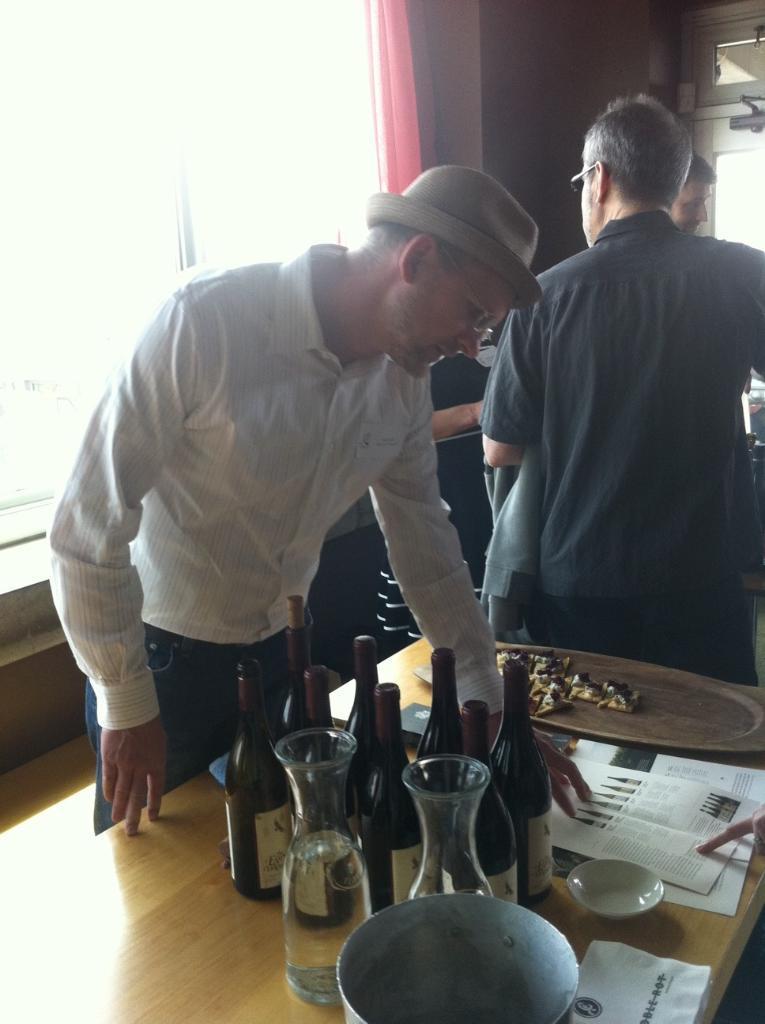Could you give a brief overview of what you see in this image? In this image, I can see few people standing. At the bottom of the image, I can see a table with glass jars, papers, bottles, a plate and few other objects. On the left side of the image, I can see a window and a curtain. 